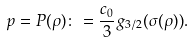<formula> <loc_0><loc_0><loc_500><loc_500>p = P ( \rho ) \colon = \frac { c _ { 0 } } { 3 } g _ { 3 / 2 } ( \sigma ( \rho ) ) .</formula> 